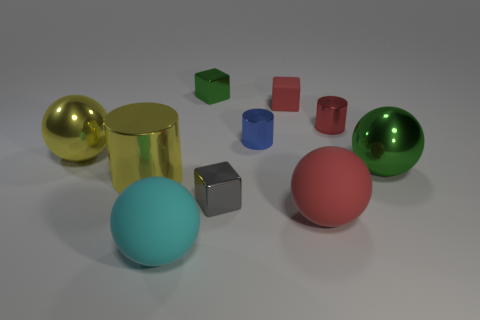Subtract all tiny cylinders. How many cylinders are left? 1 Subtract 1 spheres. How many spheres are left? 3 Subtract all red blocks. How many blocks are left? 2 Subtract 0 purple blocks. How many objects are left? 10 Subtract all balls. How many objects are left? 6 Subtract all brown spheres. Subtract all blue cylinders. How many spheres are left? 4 Subtract all brown balls. How many yellow cylinders are left? 1 Subtract all tiny green matte cylinders. Subtract all cyan balls. How many objects are left? 9 Add 5 tiny gray metallic blocks. How many tiny gray metallic blocks are left? 6 Add 8 small gray metal things. How many small gray metal things exist? 9 